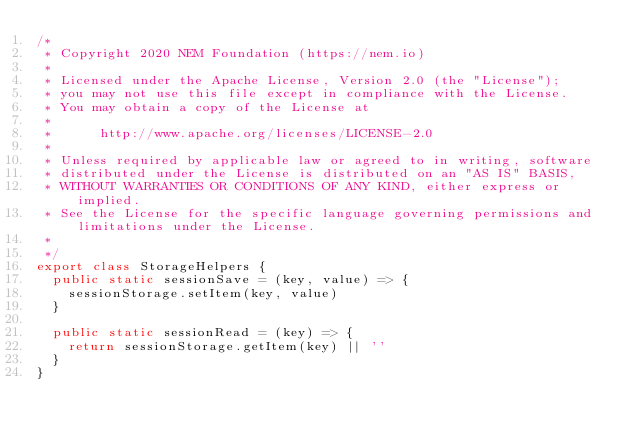<code> <loc_0><loc_0><loc_500><loc_500><_TypeScript_>/*
 * Copyright 2020 NEM Foundation (https://nem.io)
 *
 * Licensed under the Apache License, Version 2.0 (the "License");
 * you may not use this file except in compliance with the License.
 * You may obtain a copy of the License at
 *
 *      http://www.apache.org/licenses/LICENSE-2.0
 *
 * Unless required by applicable law or agreed to in writing, software
 * distributed under the License is distributed on an "AS IS" BASIS,
 * WITHOUT WARRANTIES OR CONDITIONS OF ANY KIND, either express or implied.
 * See the License for the specific language governing permissions and limitations under the License.
 *
 */
export class StorageHelpers {
  public static sessionSave = (key, value) => {
    sessionStorage.setItem(key, value)
  }

  public static sessionRead = (key) => {
    return sessionStorage.getItem(key) || ''
  }
}
</code> 